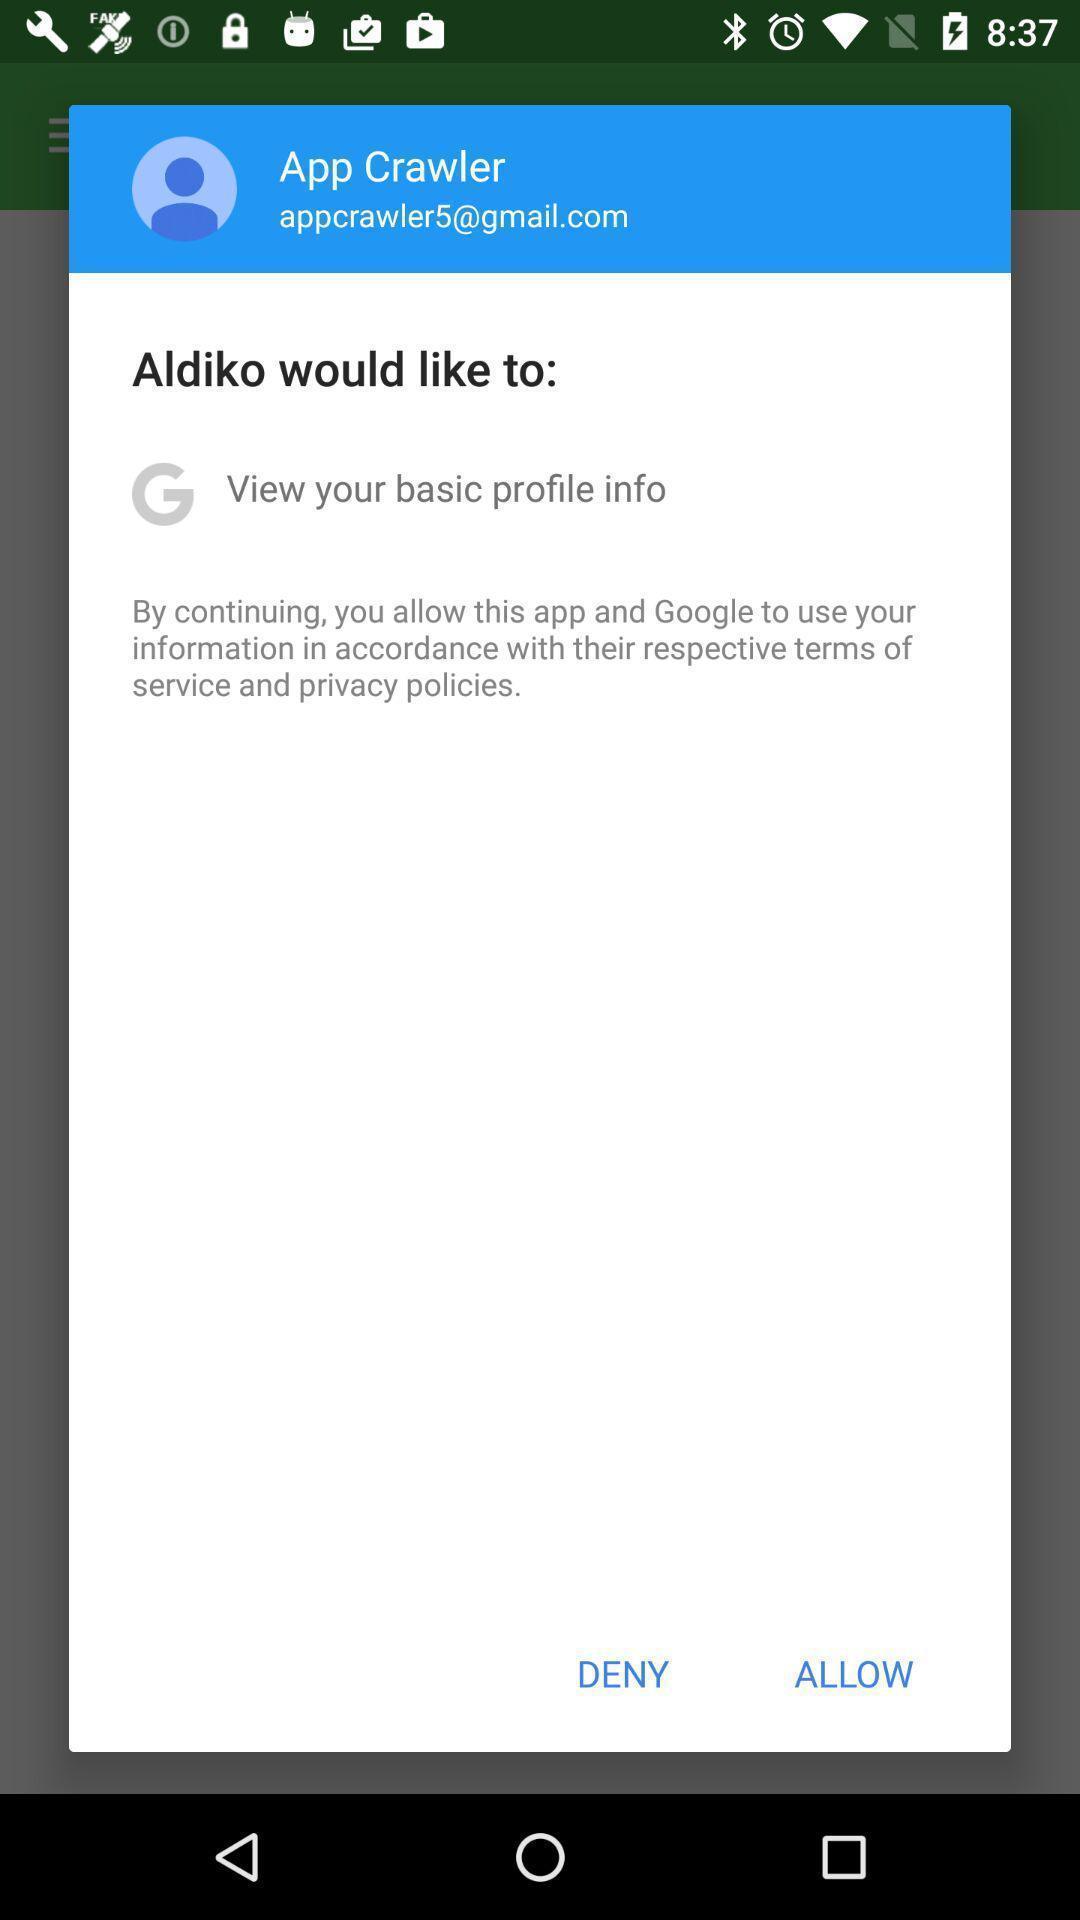Describe the content in this image. Pop up to allow the app. 